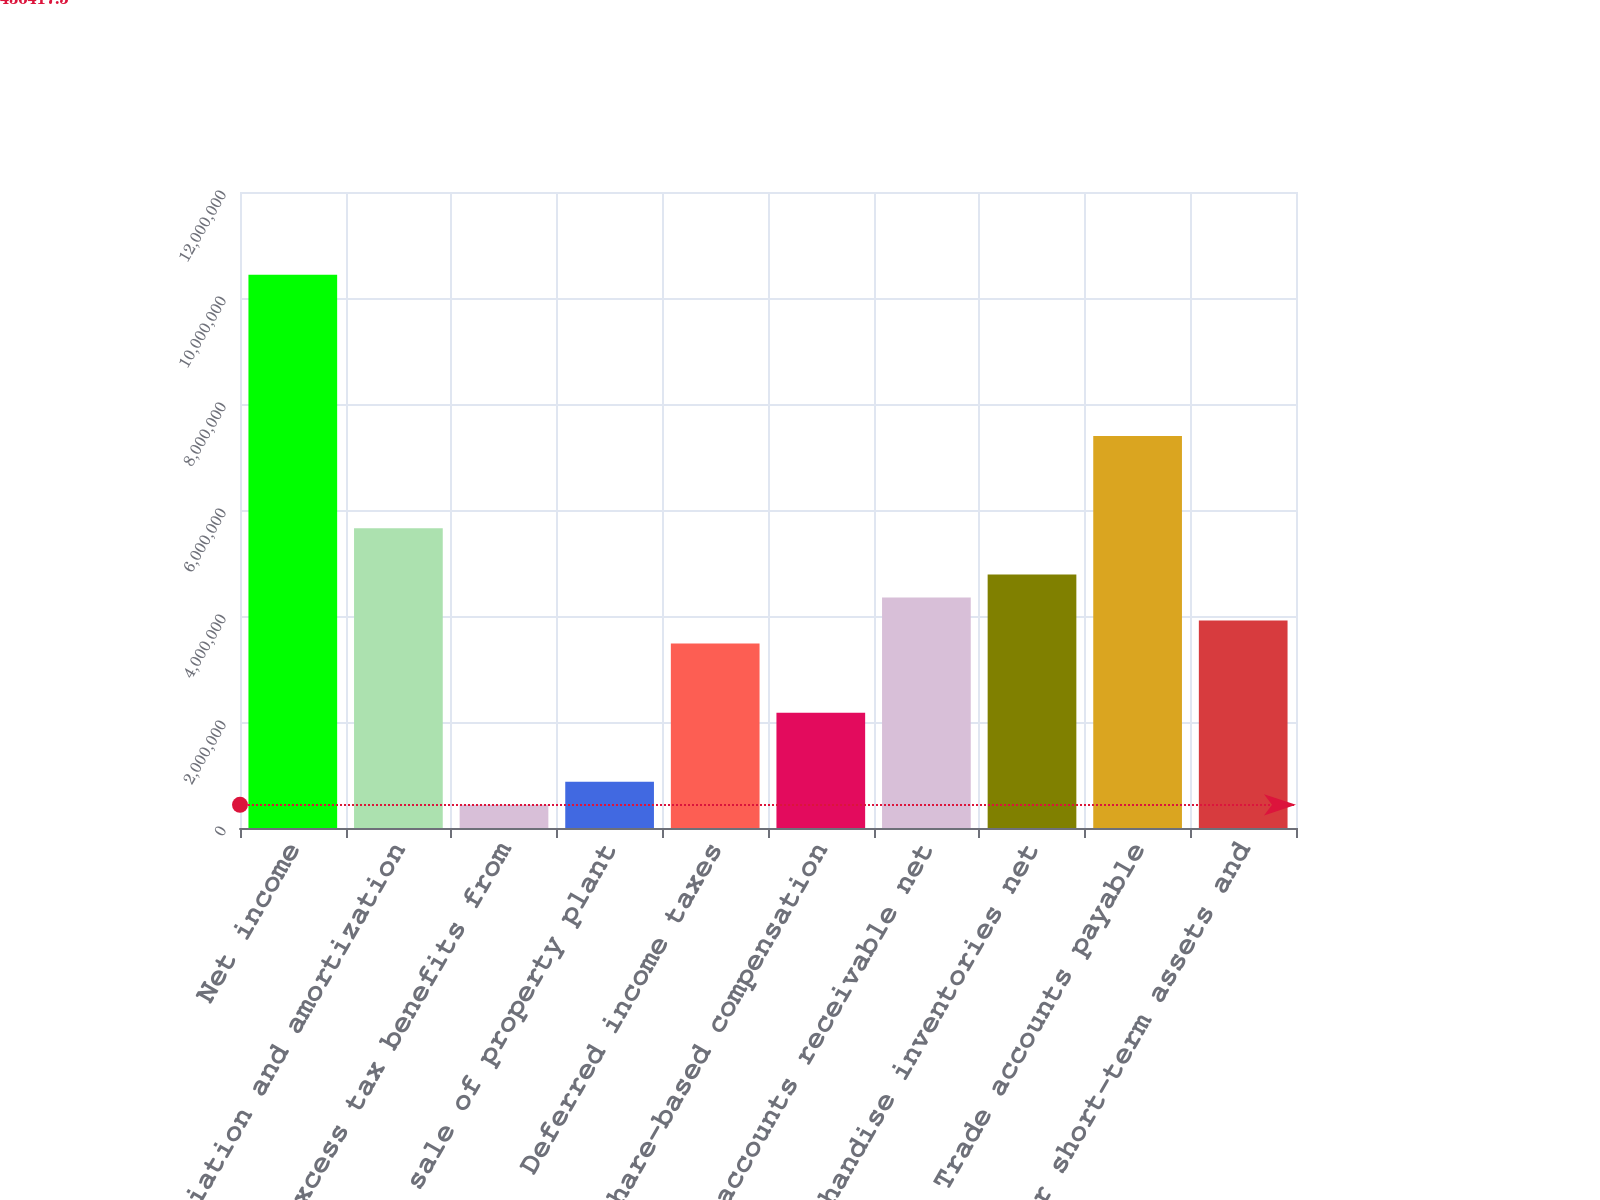Convert chart. <chart><loc_0><loc_0><loc_500><loc_500><bar_chart><fcel>Net income<fcel>Depreciation and amortization<fcel>Excess tax benefits from<fcel>Gain on sale of property plant<fcel>Deferred income taxes<fcel>Share-based compensation<fcel>Trade accounts receivable net<fcel>Merchandise inventories net<fcel>Trade accounts payable<fcel>Other short-term assets and<nl><fcel>1.04378e+07<fcel>5.65453e+06<fcel>436418<fcel>871260<fcel>3.48032e+06<fcel>2.17579e+06<fcel>4.35e+06<fcel>4.78484e+06<fcel>7.3939e+06<fcel>3.91516e+06<nl></chart> 